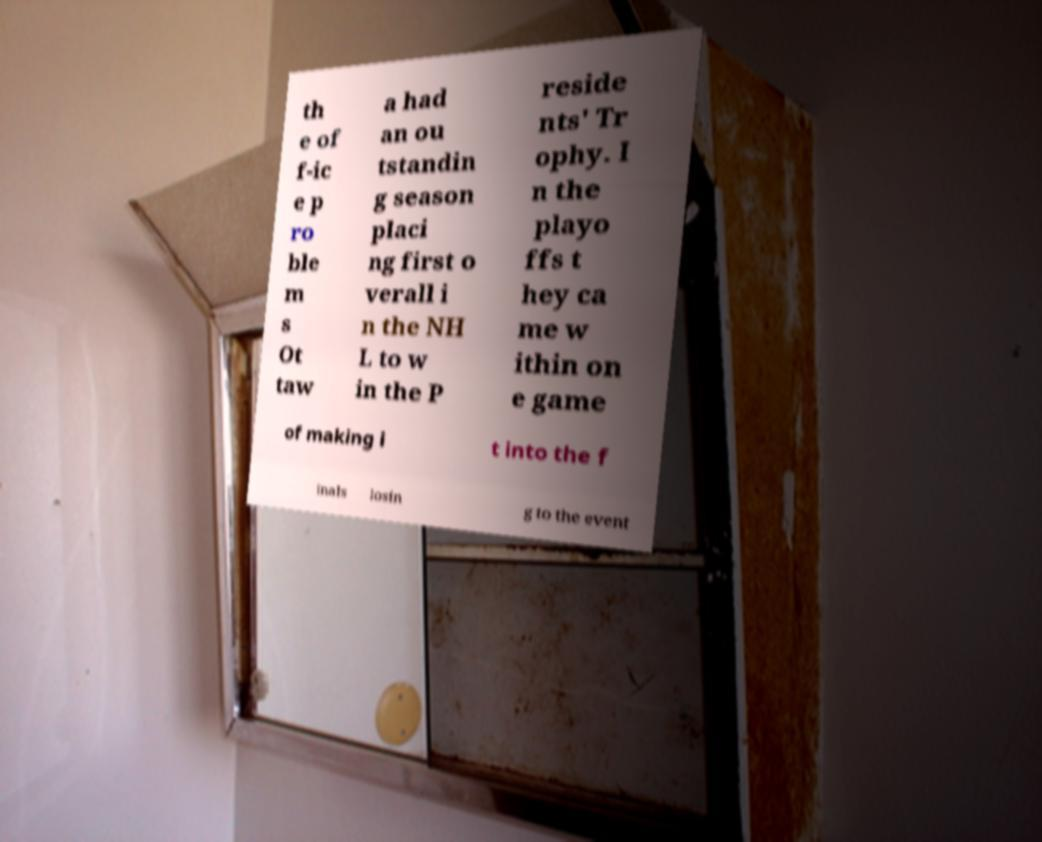Could you assist in decoding the text presented in this image and type it out clearly? th e of f-ic e p ro ble m s Ot taw a had an ou tstandin g season placi ng first o verall i n the NH L to w in the P reside nts' Tr ophy. I n the playo ffs t hey ca me w ithin on e game of making i t into the f inals losin g to the event 